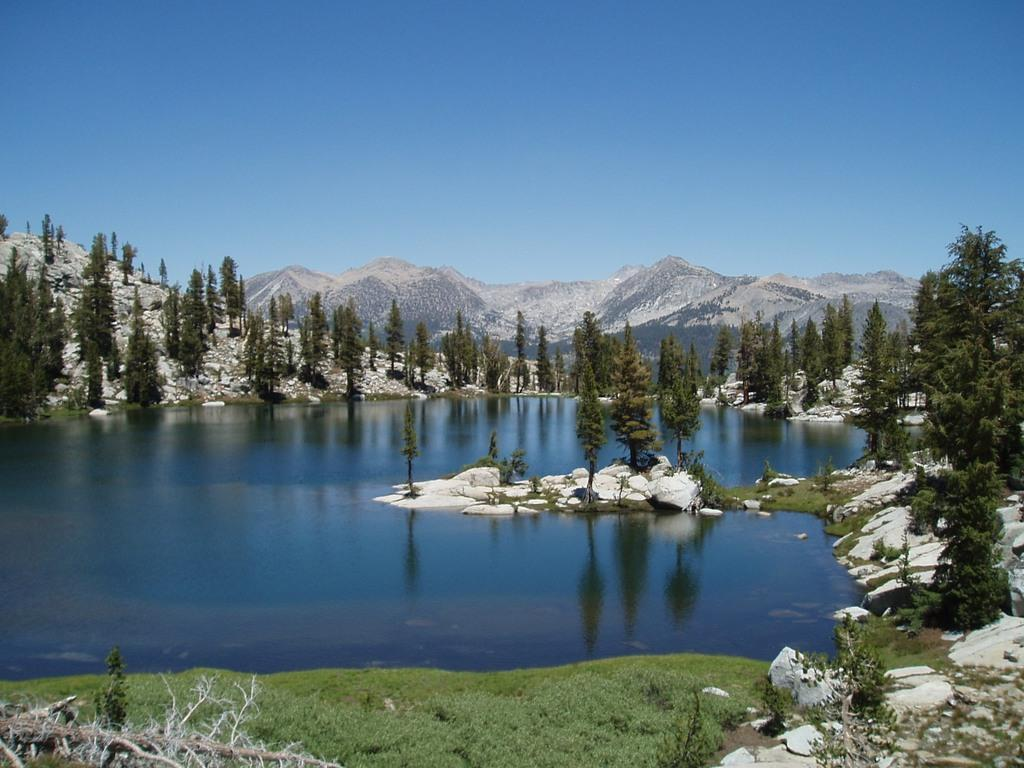What type of landscape is depicted in the image? The image features hills, trees, water, rocks, and plants, suggesting a natural landscape. Can you describe the water in the image? The water is visible in the image, but its specific characteristics are not mentioned in the facts. What color is the sky in the image? The sky is blue in the image. How many family members are visible in the image? There are no family members present in the image; it features a natural landscape. What type of guide is shown leading the group in the image? There is no guide or group present in the image; it features a natural landscape. 